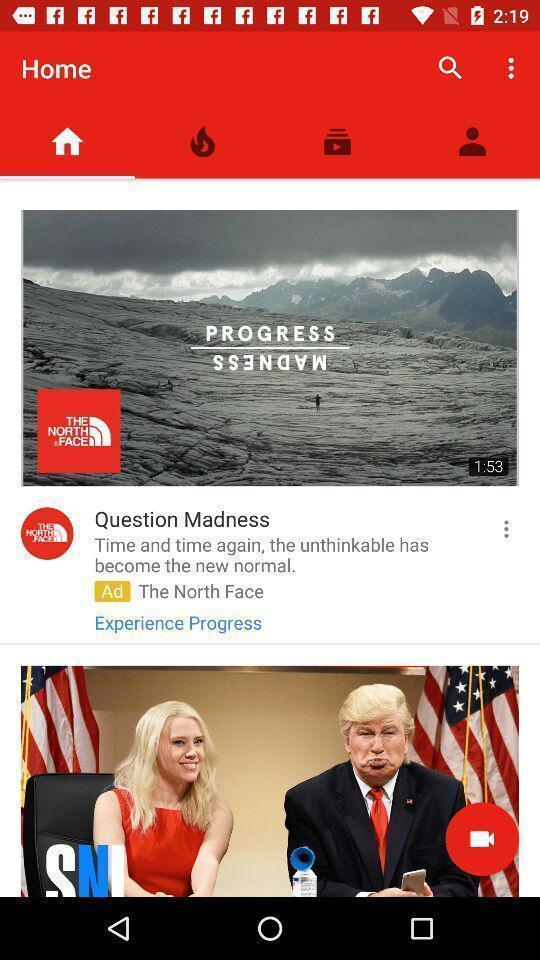Summarize the information in this screenshot. Page showing the home page of a video viewing app. 